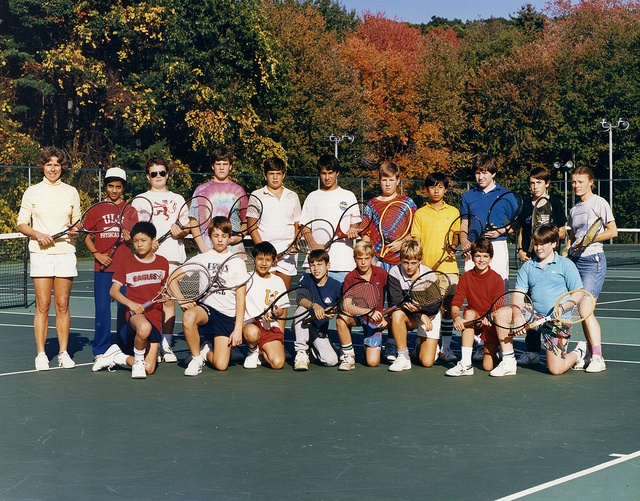Describe the objects in this image and their specific colors. I can see people in black, lightgray, gold, and brown tones, people in black, ivory, tan, and brown tones, people in black, lightgray, and tan tones, tennis racket in black, lightgray, and tan tones, and people in black, lightblue, lightgray, and tan tones in this image. 